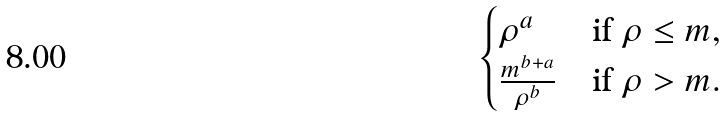Convert formula to latex. <formula><loc_0><loc_0><loc_500><loc_500>\begin{cases} \rho ^ { a } & \text {if $\rho \leq m$} , \\ \frac { m ^ { b + a } } { \rho ^ { b } } & \text {if $\rho >m$} . \end{cases}</formula> 